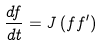<formula> <loc_0><loc_0><loc_500><loc_500>\frac { d f } { d t } = J \left ( f f ^ { \prime } \right )</formula> 